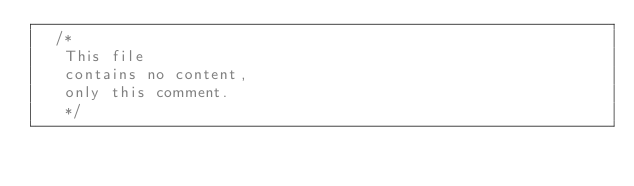Convert code to text. <code><loc_0><loc_0><loc_500><loc_500><_Ceylon_>  /*
   This file
   contains no content,
   only this comment.
   */
</code> 